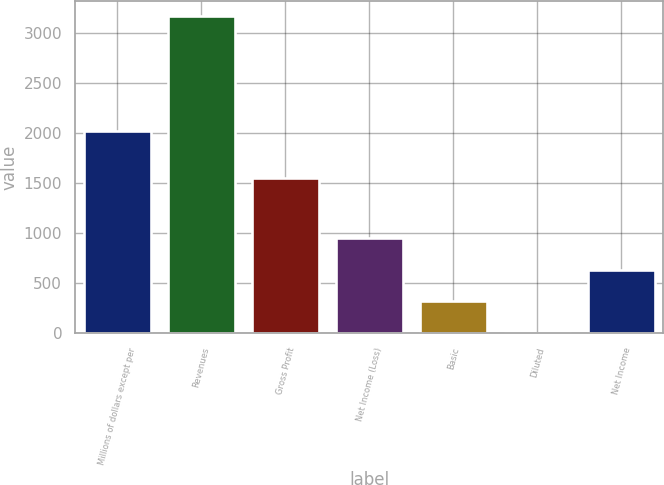Convert chart. <chart><loc_0><loc_0><loc_500><loc_500><bar_chart><fcel>Millions of dollars except per<fcel>Revenues<fcel>Gross Profit<fcel>Net Income (Loss)<fcel>Basic<fcel>Diluted<fcel>Net Income<nl><fcel>2017<fcel>3166<fcel>1554<fcel>950.68<fcel>317.72<fcel>1.24<fcel>634.2<nl></chart> 